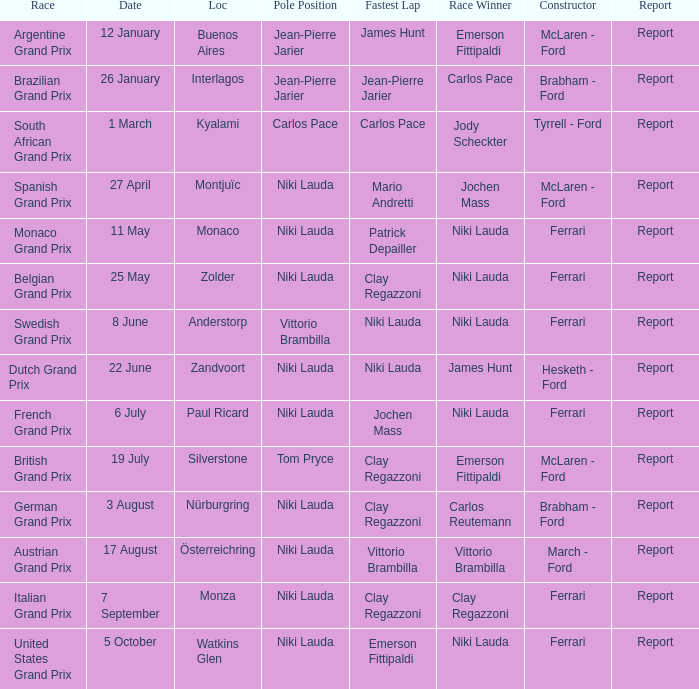Who ran the fastest lap in the team that competed in Zolder, in which Ferrari was the Constructor? Clay Regazzoni. 